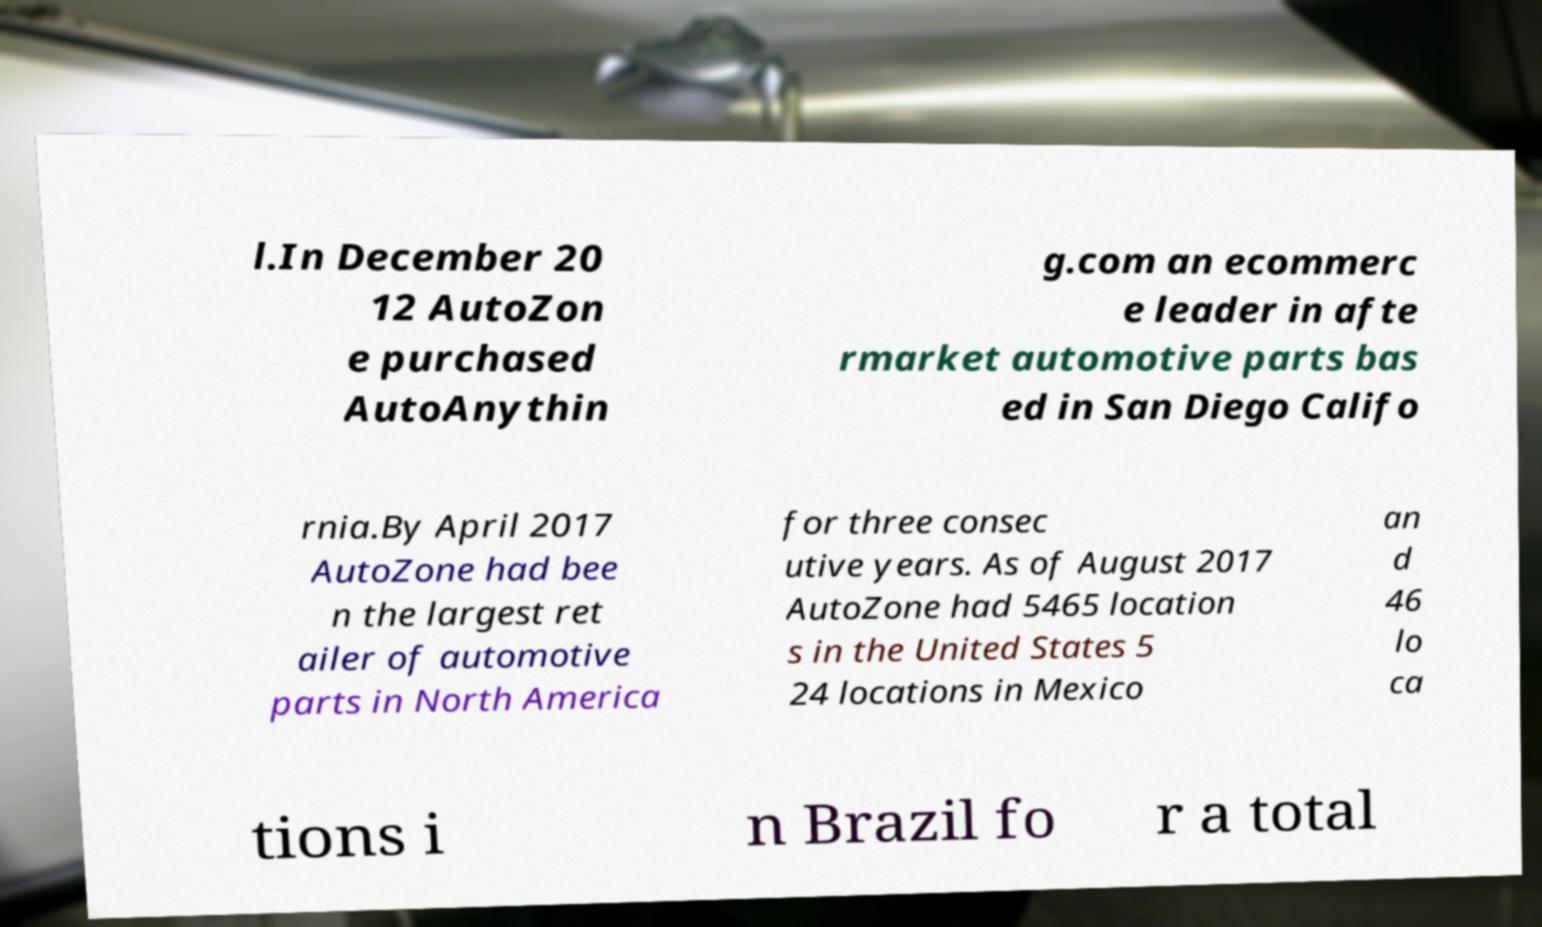What messages or text are displayed in this image? I need them in a readable, typed format. l.In December 20 12 AutoZon e purchased AutoAnythin g.com an ecommerc e leader in afte rmarket automotive parts bas ed in San Diego Califo rnia.By April 2017 AutoZone had bee n the largest ret ailer of automotive parts in North America for three consec utive years. As of August 2017 AutoZone had 5465 location s in the United States 5 24 locations in Mexico an d 46 lo ca tions i n Brazil fo r a total 